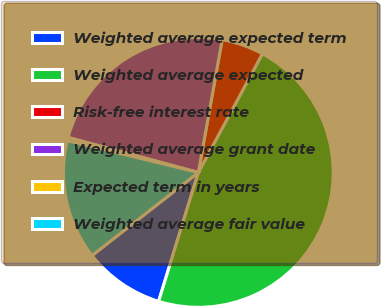Convert chart. <chart><loc_0><loc_0><loc_500><loc_500><pie_chart><fcel>Weighted average expected term<fcel>Weighted average expected<fcel>Risk-free interest rate<fcel>Weighted average grant date<fcel>Expected term in years<fcel>Weighted average fair value<nl><fcel>9.69%<fcel>46.88%<fcel>5.05%<fcel>23.64%<fcel>0.4%<fcel>14.34%<nl></chart> 